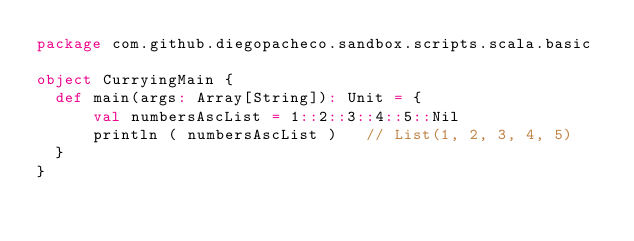Convert code to text. <code><loc_0><loc_0><loc_500><loc_500><_Scala_>package com.github.diegopacheco.sandbox.scripts.scala.basic

object CurryingMain {
  def main(args: Array[String]): Unit = {	  
	  val numbersAscList = 1::2::3::4::5::Nil
	  println ( numbersAscList )   // List(1, 2, 3, 4, 5)
  }
}</code> 